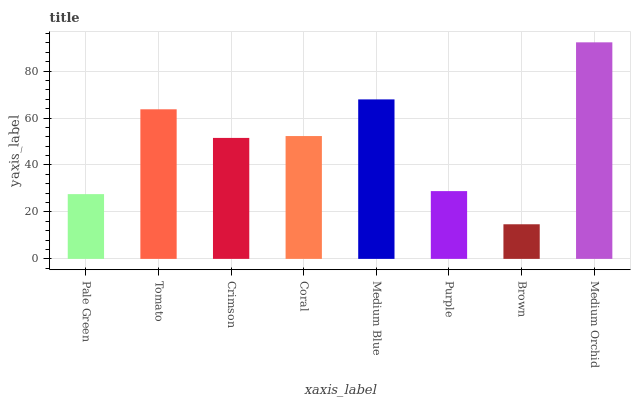Is Brown the minimum?
Answer yes or no. Yes. Is Medium Orchid the maximum?
Answer yes or no. Yes. Is Tomato the minimum?
Answer yes or no. No. Is Tomato the maximum?
Answer yes or no. No. Is Tomato greater than Pale Green?
Answer yes or no. Yes. Is Pale Green less than Tomato?
Answer yes or no. Yes. Is Pale Green greater than Tomato?
Answer yes or no. No. Is Tomato less than Pale Green?
Answer yes or no. No. Is Coral the high median?
Answer yes or no. Yes. Is Crimson the low median?
Answer yes or no. Yes. Is Brown the high median?
Answer yes or no. No. Is Coral the low median?
Answer yes or no. No. 